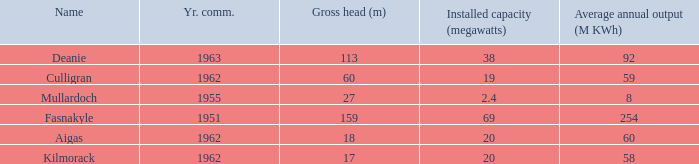What is the Year commissioned of the power station with a Gross head of 60 metres and Average annual output of less than 59 million KWh? None. 